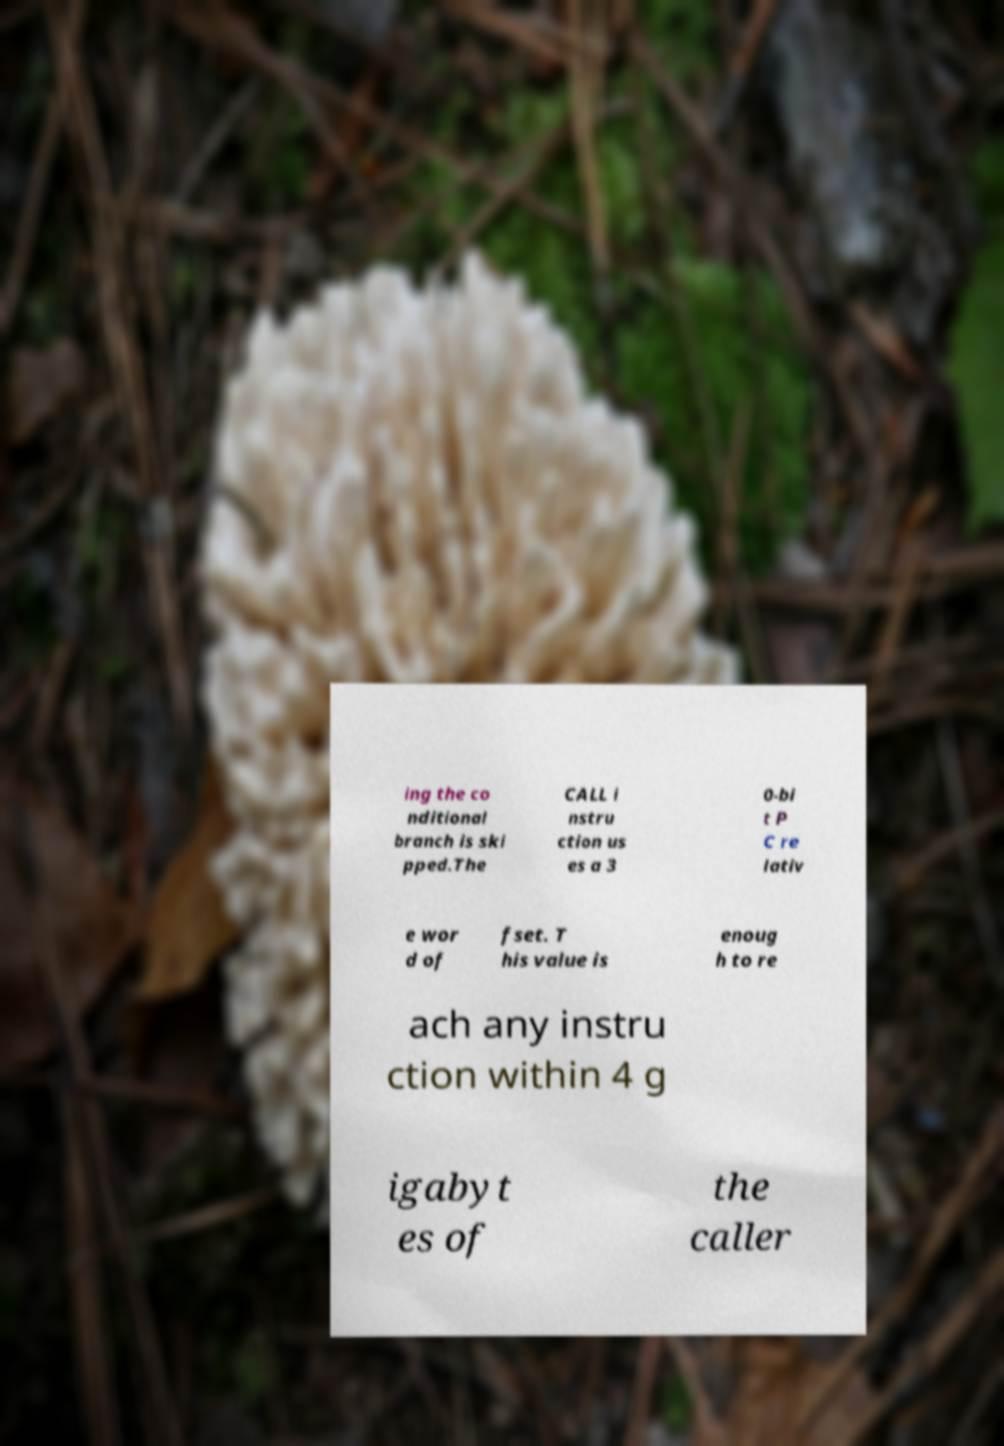Can you read and provide the text displayed in the image?This photo seems to have some interesting text. Can you extract and type it out for me? ing the co nditional branch is ski pped.The CALL i nstru ction us es a 3 0-bi t P C re lativ e wor d of fset. T his value is enoug h to re ach any instru ction within 4 g igabyt es of the caller 